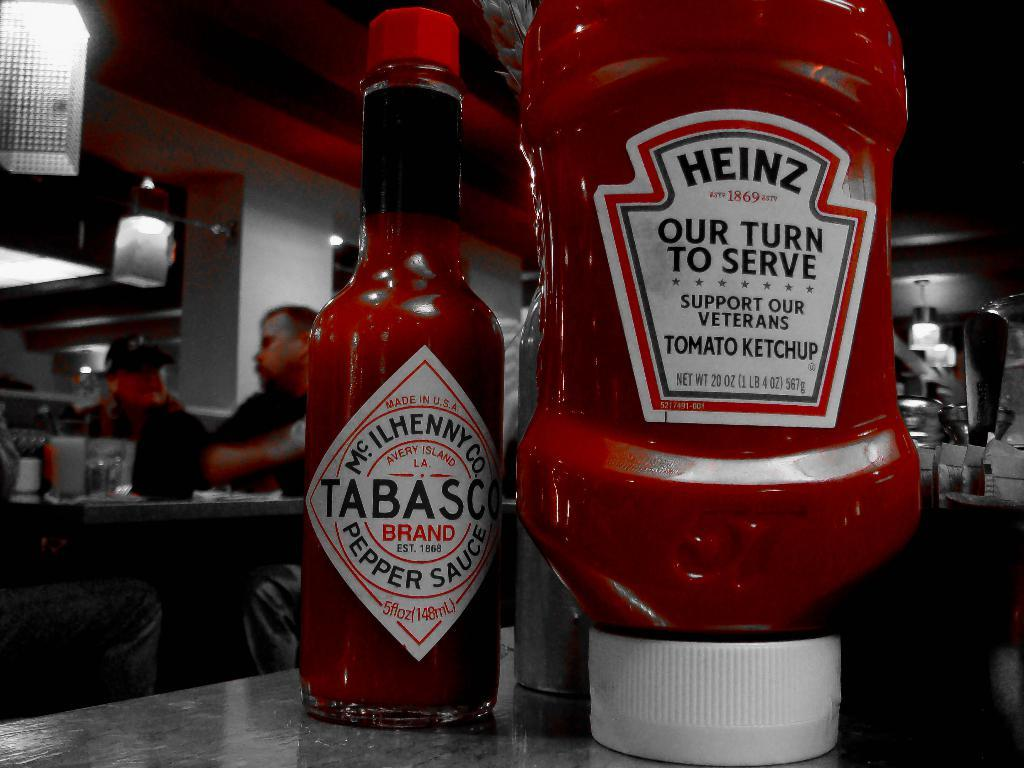What type of condiment is featured in the image? There are hot sauce bottles in the image. What is the surface on which the hot sauce bottles are placed? The hot sauce bottles are on a glass table. How many people are present in the image? There are three persons in the image. What are the persons doing in the image? The persons are sitting on chairs and having a conversation. Can you see a zipper on any of the chairs in the image? There is no mention of a zipper on any of the chairs in the image. Is there a goat present in the image? There is no goat present in the image. 